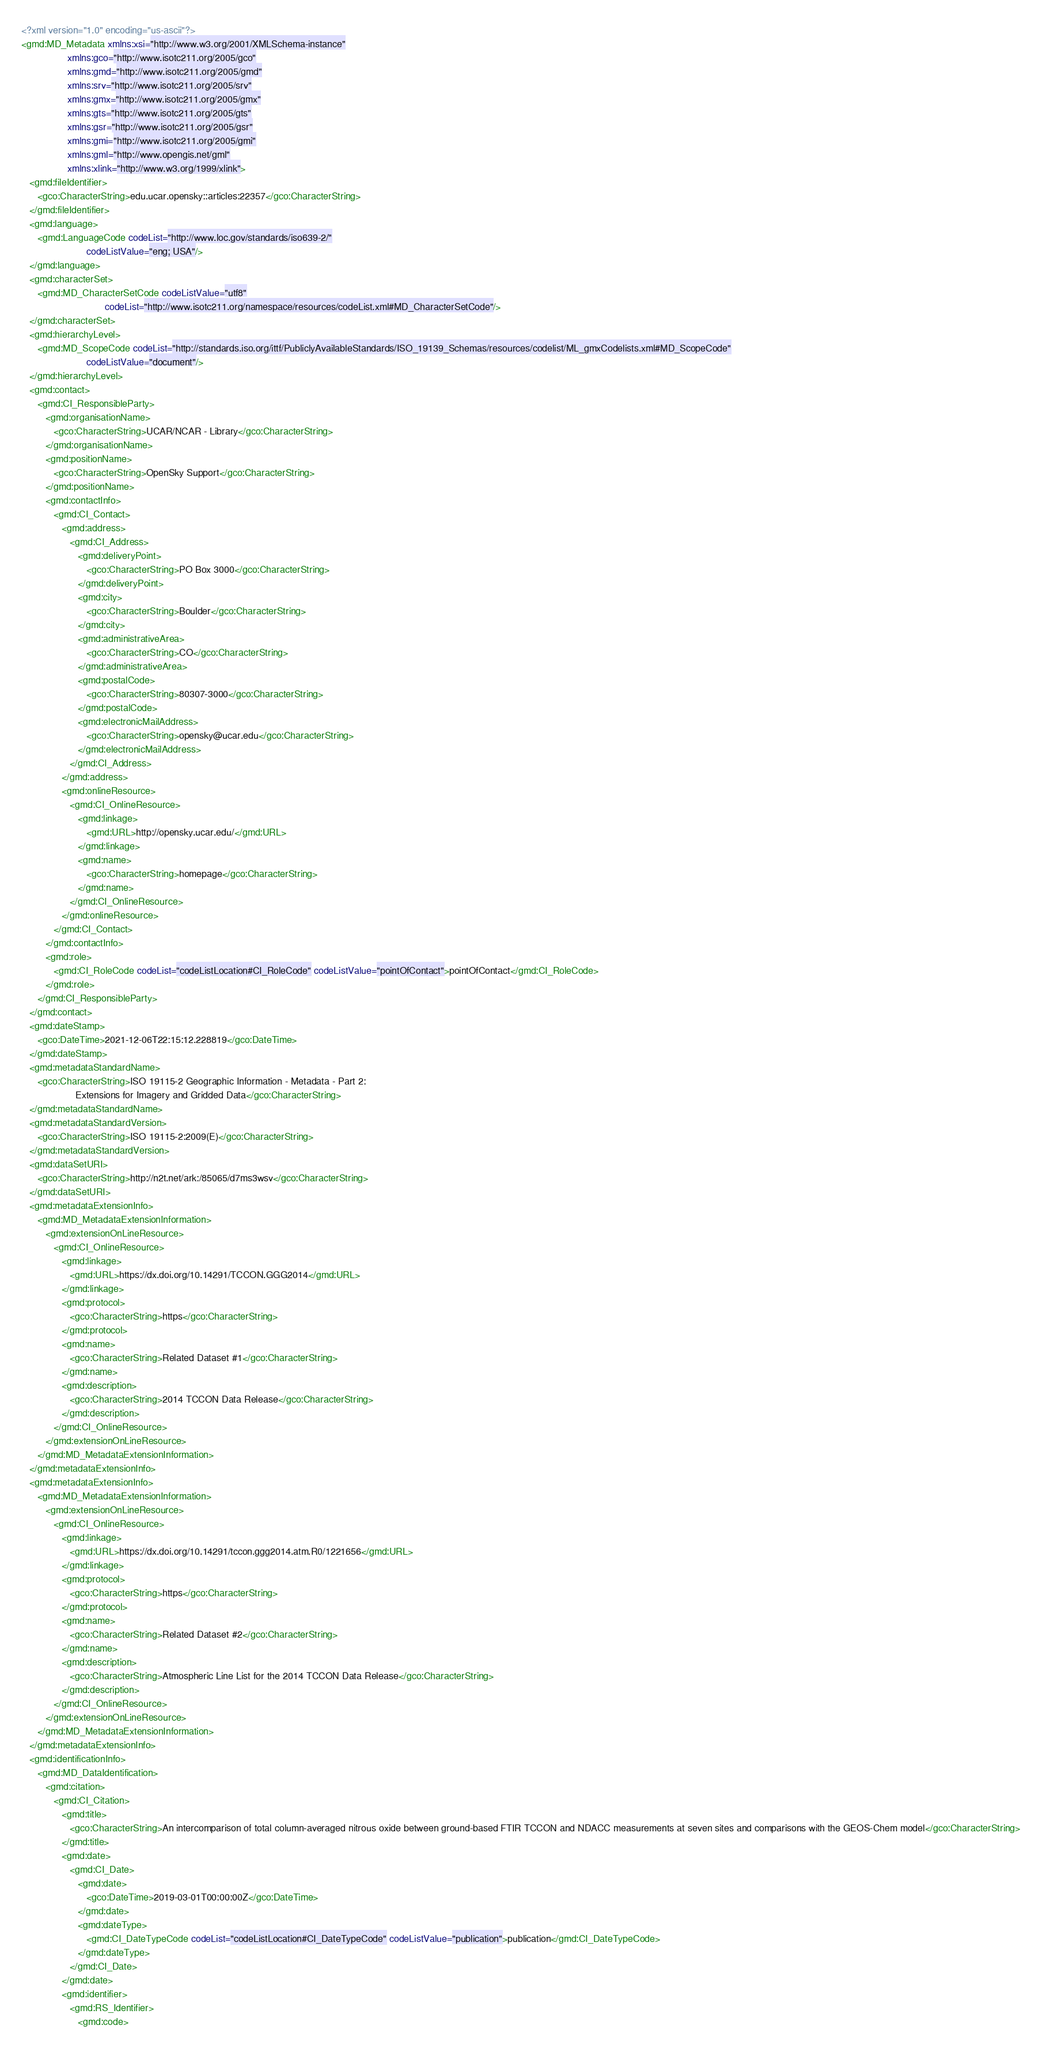<code> <loc_0><loc_0><loc_500><loc_500><_XML_><?xml version="1.0" encoding="us-ascii"?>
<gmd:MD_Metadata xmlns:xsi="http://www.w3.org/2001/XMLSchema-instance"
                 xmlns:gco="http://www.isotc211.org/2005/gco"
                 xmlns:gmd="http://www.isotc211.org/2005/gmd"
                 xmlns:srv="http://www.isotc211.org/2005/srv"
                 xmlns:gmx="http://www.isotc211.org/2005/gmx"
                 xmlns:gts="http://www.isotc211.org/2005/gts"
                 xmlns:gsr="http://www.isotc211.org/2005/gsr"
                 xmlns:gmi="http://www.isotc211.org/2005/gmi"
                 xmlns:gml="http://www.opengis.net/gml"
                 xmlns:xlink="http://www.w3.org/1999/xlink">
   <gmd:fileIdentifier>
      <gco:CharacterString>edu.ucar.opensky::articles:22357</gco:CharacterString>
   </gmd:fileIdentifier>
   <gmd:language>
      <gmd:LanguageCode codeList="http://www.loc.gov/standards/iso639-2/"
                        codeListValue="eng; USA"/>
   </gmd:language>
   <gmd:characterSet>
      <gmd:MD_CharacterSetCode codeListValue="utf8"
                               codeList="http://www.isotc211.org/namespace/resources/codeList.xml#MD_CharacterSetCode"/>
   </gmd:characterSet>
   <gmd:hierarchyLevel>
      <gmd:MD_ScopeCode codeList="http://standards.iso.org/ittf/PubliclyAvailableStandards/ISO_19139_Schemas/resources/codelist/ML_gmxCodelists.xml#MD_ScopeCode"
                        codeListValue="document"/>
   </gmd:hierarchyLevel>
   <gmd:contact>
      <gmd:CI_ResponsibleParty>
         <gmd:organisationName>
            <gco:CharacterString>UCAR/NCAR - Library</gco:CharacterString>
         </gmd:organisationName>
         <gmd:positionName>
            <gco:CharacterString>OpenSky Support</gco:CharacterString>
         </gmd:positionName>
         <gmd:contactInfo>
            <gmd:CI_Contact>
               <gmd:address>
                  <gmd:CI_Address>
                     <gmd:deliveryPoint>
                        <gco:CharacterString>PO Box 3000</gco:CharacterString>
                     </gmd:deliveryPoint>
                     <gmd:city>
                        <gco:CharacterString>Boulder</gco:CharacterString>
                     </gmd:city>
                     <gmd:administrativeArea>
                        <gco:CharacterString>CO</gco:CharacterString>
                     </gmd:administrativeArea>
                     <gmd:postalCode>
                        <gco:CharacterString>80307-3000</gco:CharacterString>
                     </gmd:postalCode>
                     <gmd:electronicMailAddress>
                        <gco:CharacterString>opensky@ucar.edu</gco:CharacterString>
                     </gmd:electronicMailAddress>
                  </gmd:CI_Address>
               </gmd:address>
               <gmd:onlineResource>
                  <gmd:CI_OnlineResource>
                     <gmd:linkage>
                        <gmd:URL>http://opensky.ucar.edu/</gmd:URL>
                     </gmd:linkage>
                     <gmd:name>
                        <gco:CharacterString>homepage</gco:CharacterString>
                     </gmd:name>
                  </gmd:CI_OnlineResource>
               </gmd:onlineResource>
            </gmd:CI_Contact>
         </gmd:contactInfo>
         <gmd:role>
            <gmd:CI_RoleCode codeList="codeListLocation#CI_RoleCode" codeListValue="pointOfContact">pointOfContact</gmd:CI_RoleCode>
         </gmd:role>
      </gmd:CI_ResponsibleParty>
   </gmd:contact>
   <gmd:dateStamp>
      <gco:DateTime>2021-12-06T22:15:12.228819</gco:DateTime>
   </gmd:dateStamp>
   <gmd:metadataStandardName>
      <gco:CharacterString>ISO 19115-2 Geographic Information - Metadata - Part 2:
                    Extensions for Imagery and Gridded Data</gco:CharacterString>
   </gmd:metadataStandardName>
   <gmd:metadataStandardVersion>
      <gco:CharacterString>ISO 19115-2:2009(E)</gco:CharacterString>
   </gmd:metadataStandardVersion>
   <gmd:dataSetURI>
      <gco:CharacterString>http://n2t.net/ark:/85065/d7ms3wsv</gco:CharacterString>
   </gmd:dataSetURI>
   <gmd:metadataExtensionInfo>
      <gmd:MD_MetadataExtensionInformation>
         <gmd:extensionOnLineResource>
            <gmd:CI_OnlineResource>
               <gmd:linkage>
                  <gmd:URL>https://dx.doi.org/10.14291/TCCON.GGG2014</gmd:URL>
               </gmd:linkage>
               <gmd:protocol>
                  <gco:CharacterString>https</gco:CharacterString>
               </gmd:protocol>
               <gmd:name>
                  <gco:CharacterString>Related Dataset #1</gco:CharacterString>
               </gmd:name>
               <gmd:description>
                  <gco:CharacterString>2014 TCCON Data Release</gco:CharacterString>
               </gmd:description>
            </gmd:CI_OnlineResource>
         </gmd:extensionOnLineResource>
      </gmd:MD_MetadataExtensionInformation>
   </gmd:metadataExtensionInfo>
   <gmd:metadataExtensionInfo>
      <gmd:MD_MetadataExtensionInformation>
         <gmd:extensionOnLineResource>
            <gmd:CI_OnlineResource>
               <gmd:linkage>
                  <gmd:URL>https://dx.doi.org/10.14291/tccon.ggg2014.atm.R0/1221656</gmd:URL>
               </gmd:linkage>
               <gmd:protocol>
                  <gco:CharacterString>https</gco:CharacterString>
               </gmd:protocol>
               <gmd:name>
                  <gco:CharacterString>Related Dataset #2</gco:CharacterString>
               </gmd:name>
               <gmd:description>
                  <gco:CharacterString>Atmospheric Line List for the 2014 TCCON Data Release</gco:CharacterString>
               </gmd:description>
            </gmd:CI_OnlineResource>
         </gmd:extensionOnLineResource>
      </gmd:MD_MetadataExtensionInformation>
   </gmd:metadataExtensionInfo>
   <gmd:identificationInfo>
      <gmd:MD_DataIdentification>
         <gmd:citation>
            <gmd:CI_Citation>
               <gmd:title>
                  <gco:CharacterString>An intercomparison of total column-averaged nitrous oxide between ground-based FTIR TCCON and NDACC measurements at seven sites and comparisons with the GEOS-Chem model</gco:CharacterString>
               </gmd:title>
               <gmd:date>
                  <gmd:CI_Date>
                     <gmd:date>
                        <gco:DateTime>2019-03-01T00:00:00Z</gco:DateTime>
                     </gmd:date>
                     <gmd:dateType>
                        <gmd:CI_DateTypeCode codeList="codeListLocation#CI_DateTypeCode" codeListValue="publication">publication</gmd:CI_DateTypeCode>
                     </gmd:dateType>
                  </gmd:CI_Date>
               </gmd:date>
               <gmd:identifier>
                  <gmd:RS_Identifier>
                     <gmd:code></code> 